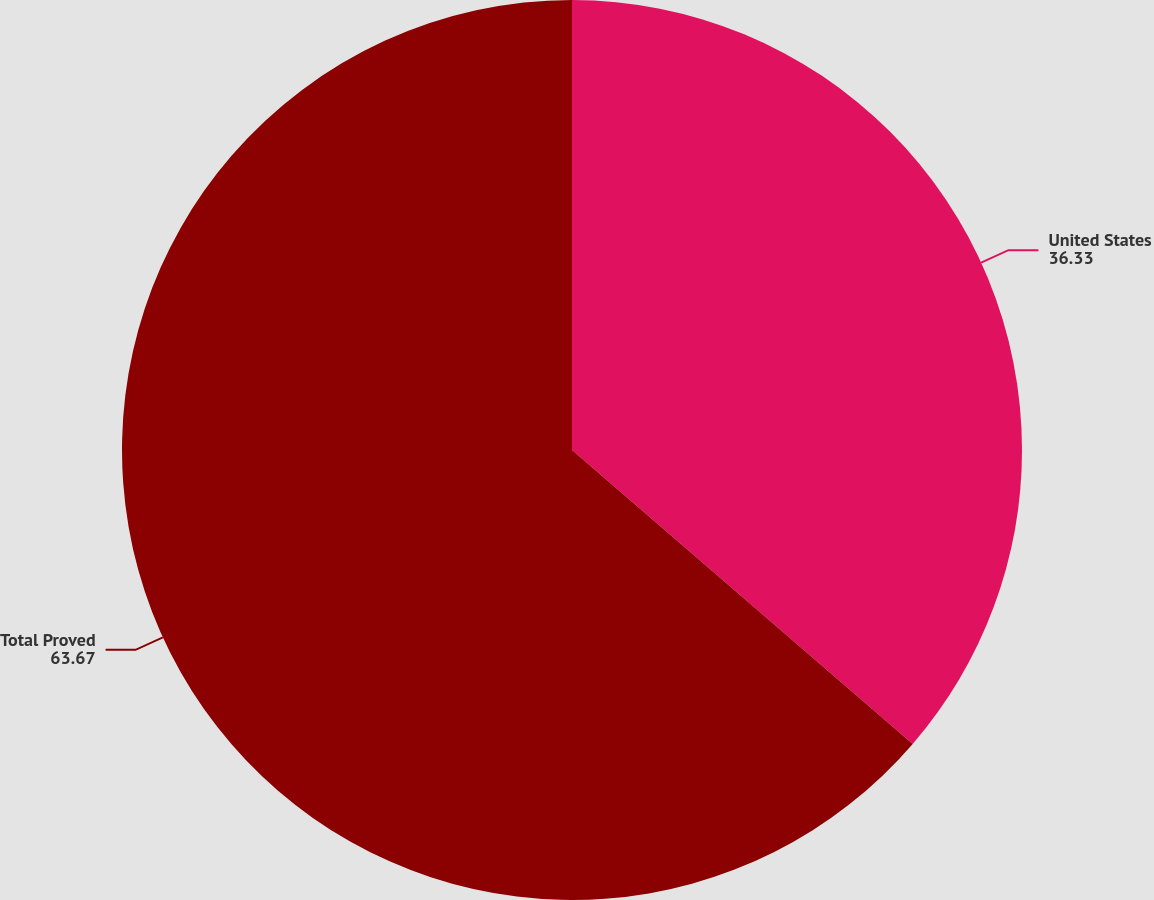Convert chart. <chart><loc_0><loc_0><loc_500><loc_500><pie_chart><fcel>United States<fcel>Total Proved<nl><fcel>36.33%<fcel>63.67%<nl></chart> 